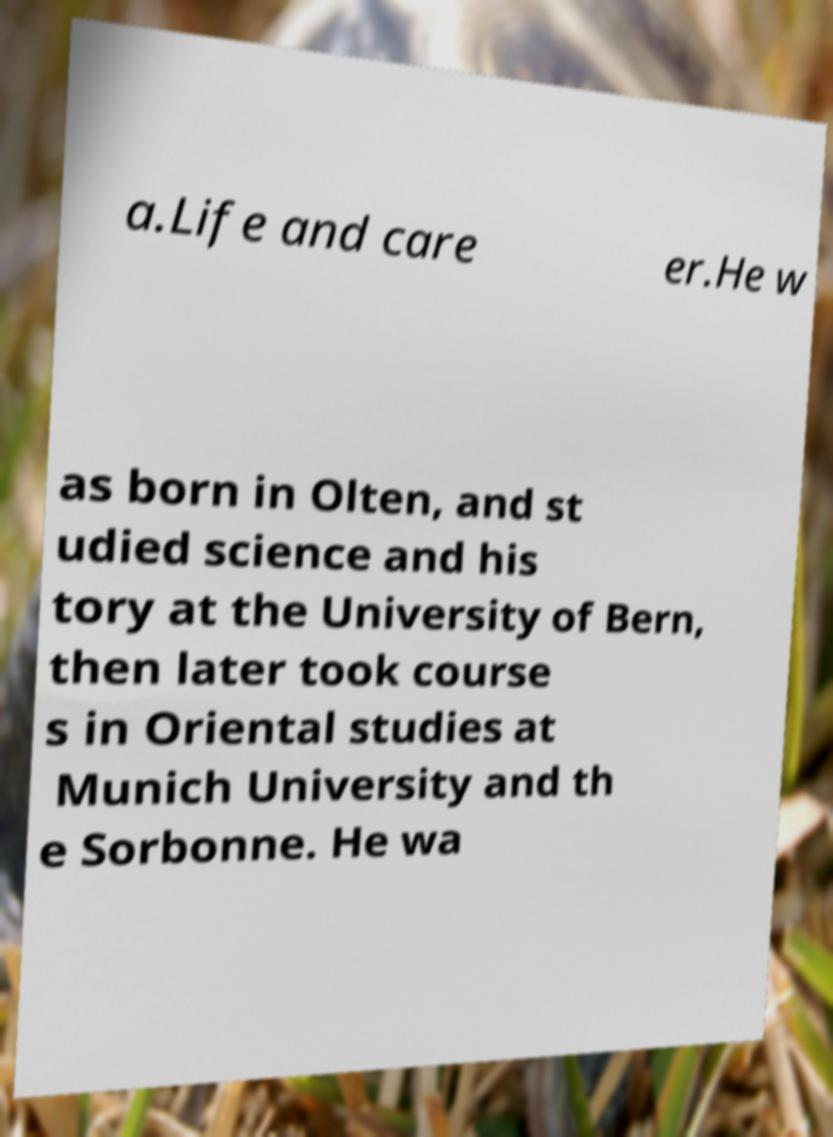Can you read and provide the text displayed in the image?This photo seems to have some interesting text. Can you extract and type it out for me? a.Life and care er.He w as born in Olten, and st udied science and his tory at the University of Bern, then later took course s in Oriental studies at Munich University and th e Sorbonne. He wa 